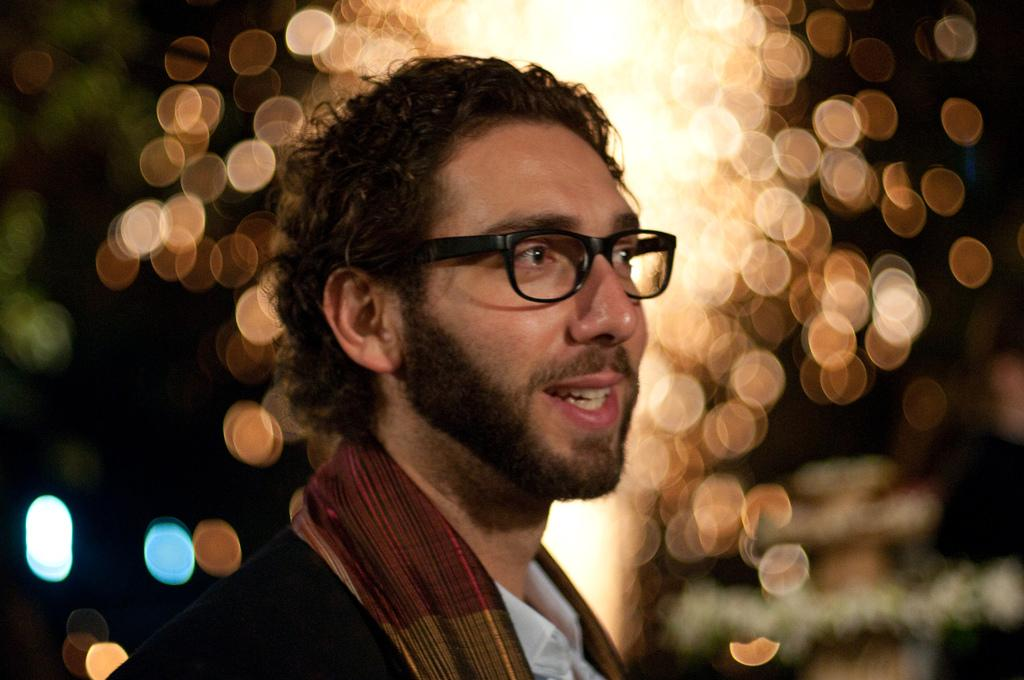Who is present in the image? There is a man in the image. What is the man wearing on his face? The man is wearing spectacles. What can be seen in the background of the image? There are lights visible in the background of the image. What type of history is the man teaching in the image? There is no indication in the image that the man is teaching history or any other subject. 